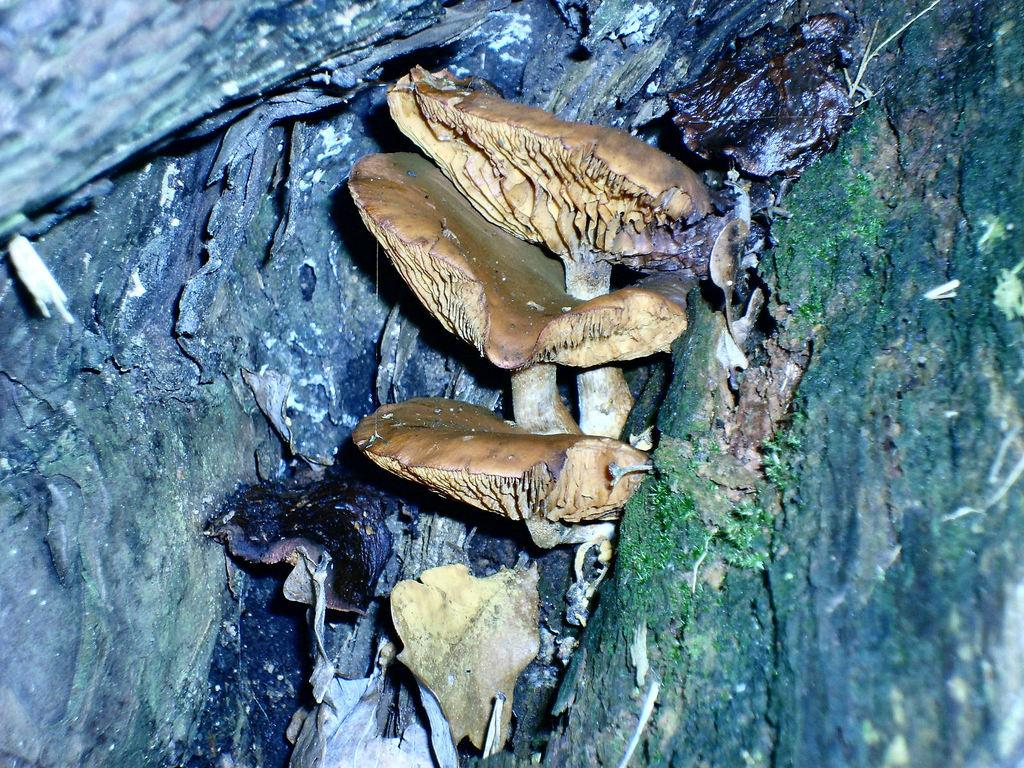What can be seen in the image? There are objects in the image. What is the color of the objects? The objects are brown in color. Where are the objects located? The objects are on a tree trunk. How many cakes are being served to the visitors in the image? There are no cakes or visitors present in the image; it only features brown objects on a tree trunk. 